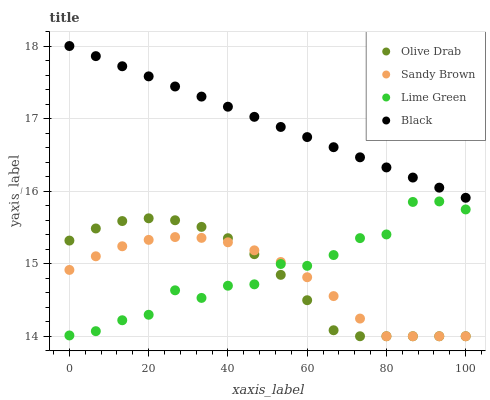Does Sandy Brown have the minimum area under the curve?
Answer yes or no. Yes. Does Black have the maximum area under the curve?
Answer yes or no. Yes. Does Olive Drab have the minimum area under the curve?
Answer yes or no. No. Does Olive Drab have the maximum area under the curve?
Answer yes or no. No. Is Black the smoothest?
Answer yes or no. Yes. Is Lime Green the roughest?
Answer yes or no. Yes. Is Sandy Brown the smoothest?
Answer yes or no. No. Is Sandy Brown the roughest?
Answer yes or no. No. Does Sandy Brown have the lowest value?
Answer yes or no. Yes. Does Black have the lowest value?
Answer yes or no. No. Does Black have the highest value?
Answer yes or no. Yes. Does Olive Drab have the highest value?
Answer yes or no. No. Is Sandy Brown less than Black?
Answer yes or no. Yes. Is Black greater than Lime Green?
Answer yes or no. Yes. Does Olive Drab intersect Sandy Brown?
Answer yes or no. Yes. Is Olive Drab less than Sandy Brown?
Answer yes or no. No. Is Olive Drab greater than Sandy Brown?
Answer yes or no. No. Does Sandy Brown intersect Black?
Answer yes or no. No. 